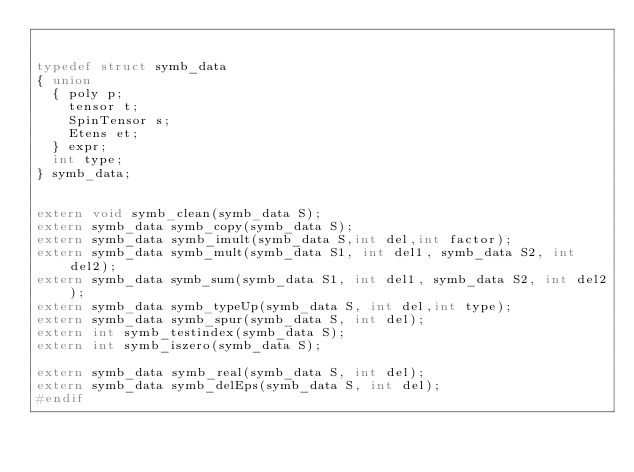<code> <loc_0><loc_0><loc_500><loc_500><_C_>

typedef struct symb_data
{ union
  { poly p;
    tensor t;
    SpinTensor s;
    Etens et;
  } expr;
  int type;
} symb_data;

                  
extern void symb_clean(symb_data S);
extern symb_data symb_copy(symb_data S);
extern symb_data symb_imult(symb_data S,int del,int factor);
extern symb_data symb_mult(symb_data S1, int del1, symb_data S2, int del2);
extern symb_data symb_sum(symb_data S1, int del1, symb_data S2, int del2);
extern symb_data symb_typeUp(symb_data S, int del,int type);
extern symb_data symb_spur(symb_data S, int del);
extern int symb_testindex(symb_data S);
extern int symb_iszero(symb_data S);

extern symb_data symb_real(symb_data S, int del);
extern symb_data symb_delEps(symb_data S, int del);
#endif
</code> 